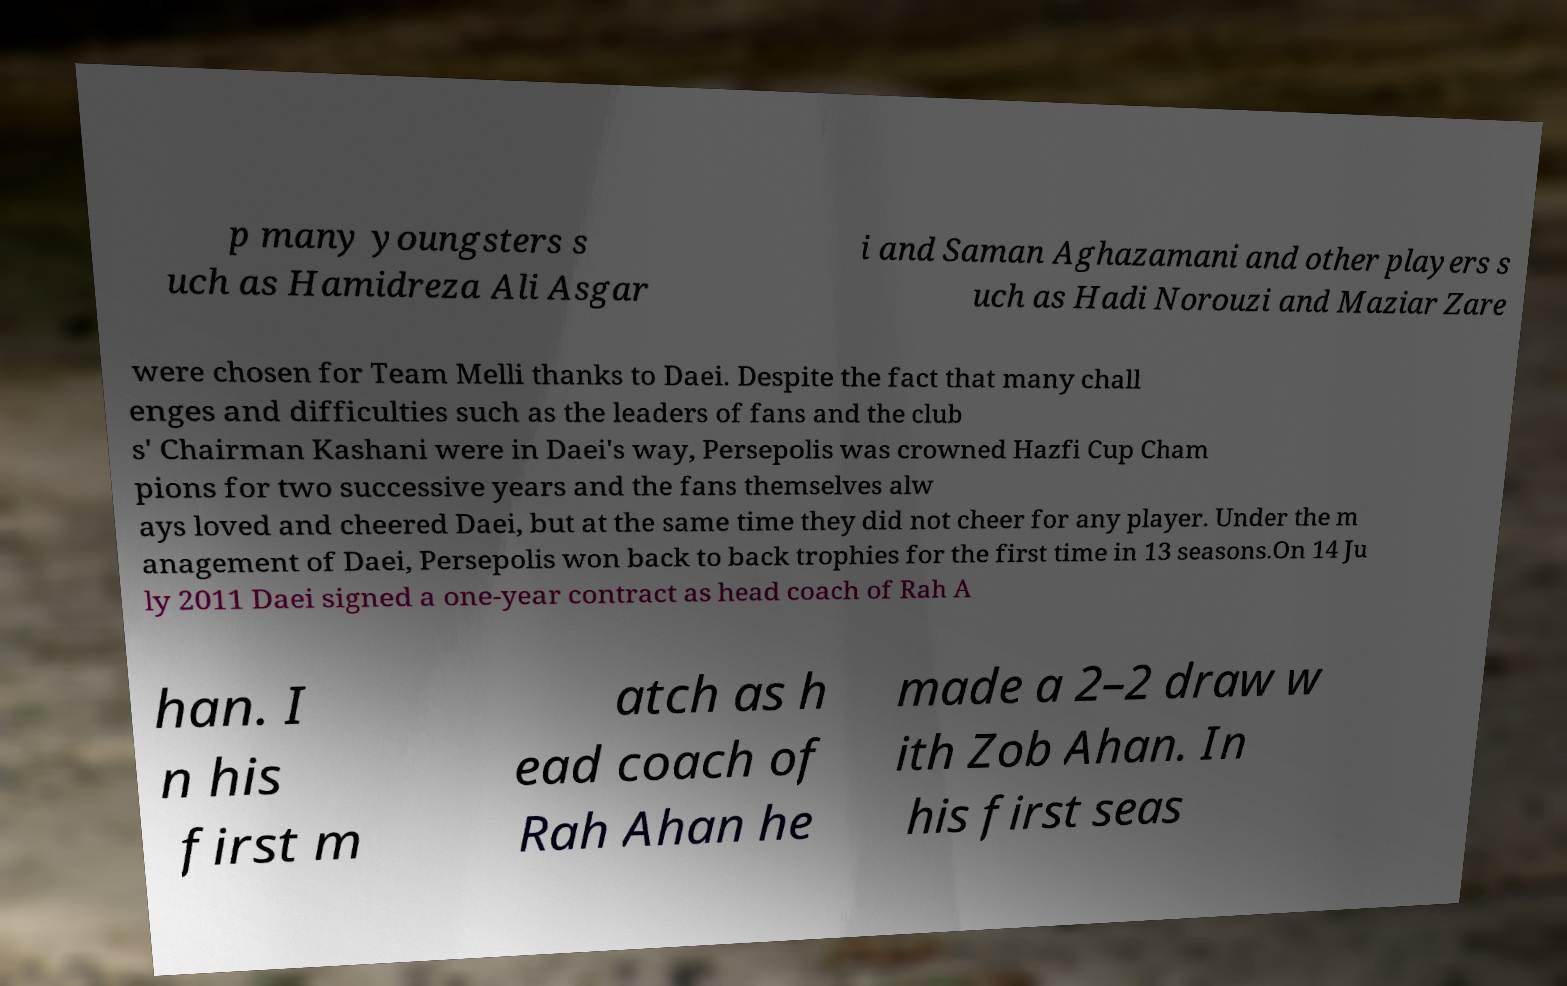I need the written content from this picture converted into text. Can you do that? p many youngsters s uch as Hamidreza Ali Asgar i and Saman Aghazamani and other players s uch as Hadi Norouzi and Maziar Zare were chosen for Team Melli thanks to Daei. Despite the fact that many chall enges and difficulties such as the leaders of fans and the club s' Chairman Kashani were in Daei's way, Persepolis was crowned Hazfi Cup Cham pions for two successive years and the fans themselves alw ays loved and cheered Daei, but at the same time they did not cheer for any player. Under the m anagement of Daei, Persepolis won back to back trophies for the first time in 13 seasons.On 14 Ju ly 2011 Daei signed a one-year contract as head coach of Rah A han. I n his first m atch as h ead coach of Rah Ahan he made a 2–2 draw w ith Zob Ahan. In his first seas 